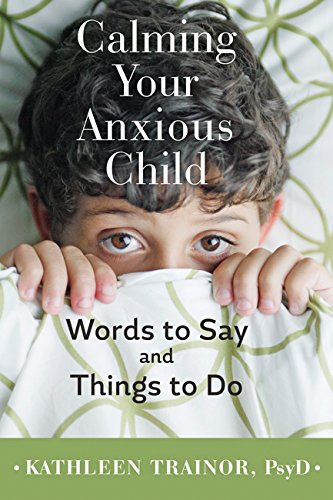Is this a motivational book? Yes, this book serves a motivational purpose by empowering parents with techniques and insights to help their children overcome anxiety. 